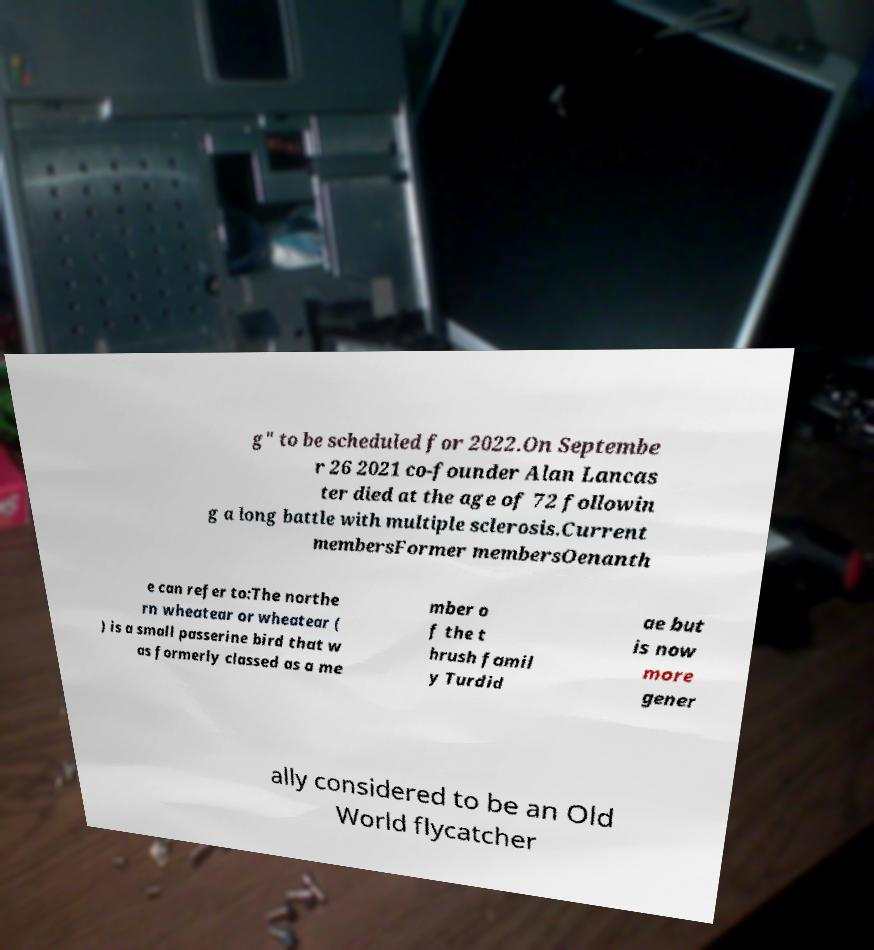Can you read and provide the text displayed in the image?This photo seems to have some interesting text. Can you extract and type it out for me? g" to be scheduled for 2022.On Septembe r 26 2021 co-founder Alan Lancas ter died at the age of 72 followin g a long battle with multiple sclerosis.Current membersFormer membersOenanth e can refer to:The northe rn wheatear or wheatear ( ) is a small passerine bird that w as formerly classed as a me mber o f the t hrush famil y Turdid ae but is now more gener ally considered to be an Old World flycatcher 